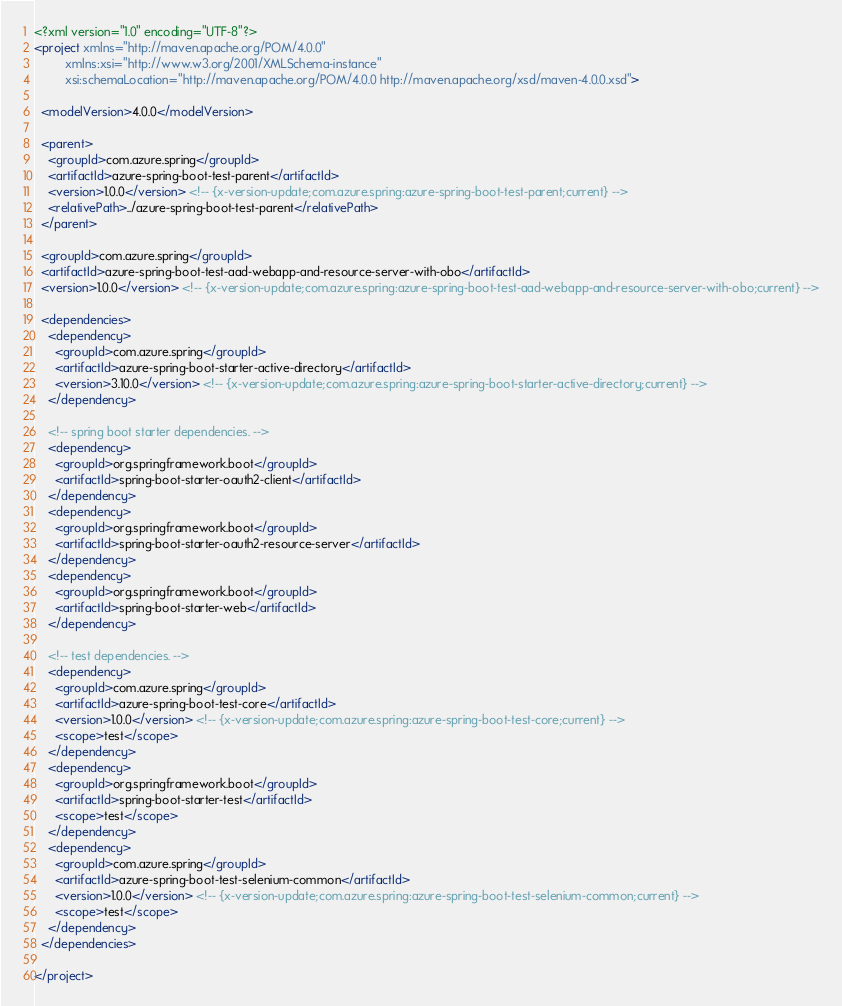Convert code to text. <code><loc_0><loc_0><loc_500><loc_500><_XML_><?xml version="1.0" encoding="UTF-8"?>
<project xmlns="http://maven.apache.org/POM/4.0.0"
         xmlns:xsi="http://www.w3.org/2001/XMLSchema-instance"
         xsi:schemaLocation="http://maven.apache.org/POM/4.0.0 http://maven.apache.org/xsd/maven-4.0.0.xsd">

  <modelVersion>4.0.0</modelVersion>

  <parent>
    <groupId>com.azure.spring</groupId>
    <artifactId>azure-spring-boot-test-parent</artifactId>
    <version>1.0.0</version> <!-- {x-version-update;com.azure.spring:azure-spring-boot-test-parent;current} -->
    <relativePath>../azure-spring-boot-test-parent</relativePath>
  </parent>

  <groupId>com.azure.spring</groupId>
  <artifactId>azure-spring-boot-test-aad-webapp-and-resource-server-with-obo</artifactId>
  <version>1.0.0</version> <!-- {x-version-update;com.azure.spring:azure-spring-boot-test-aad-webapp-and-resource-server-with-obo;current} -->

  <dependencies>
    <dependency>
      <groupId>com.azure.spring</groupId>
      <artifactId>azure-spring-boot-starter-active-directory</artifactId>
      <version>3.10.0</version> <!-- {x-version-update;com.azure.spring:azure-spring-boot-starter-active-directory;current} -->
    </dependency>

    <!-- spring boot starter dependencies. -->
    <dependency>
      <groupId>org.springframework.boot</groupId>
      <artifactId>spring-boot-starter-oauth2-client</artifactId>
    </dependency>
    <dependency>
      <groupId>org.springframework.boot</groupId>
      <artifactId>spring-boot-starter-oauth2-resource-server</artifactId>
    </dependency>
    <dependency>
      <groupId>org.springframework.boot</groupId>
      <artifactId>spring-boot-starter-web</artifactId>
    </dependency>

    <!-- test dependencies. -->
    <dependency>
      <groupId>com.azure.spring</groupId>
      <artifactId>azure-spring-boot-test-core</artifactId>
      <version>1.0.0</version> <!-- {x-version-update;com.azure.spring:azure-spring-boot-test-core;current} -->
      <scope>test</scope>
    </dependency>
    <dependency>
      <groupId>org.springframework.boot</groupId>
      <artifactId>spring-boot-starter-test</artifactId>
      <scope>test</scope>
    </dependency>
    <dependency>
      <groupId>com.azure.spring</groupId>
      <artifactId>azure-spring-boot-test-selenium-common</artifactId>
      <version>1.0.0</version> <!-- {x-version-update;com.azure.spring:azure-spring-boot-test-selenium-common;current} -->
      <scope>test</scope>
    </dependency>
  </dependencies>

</project>
</code> 